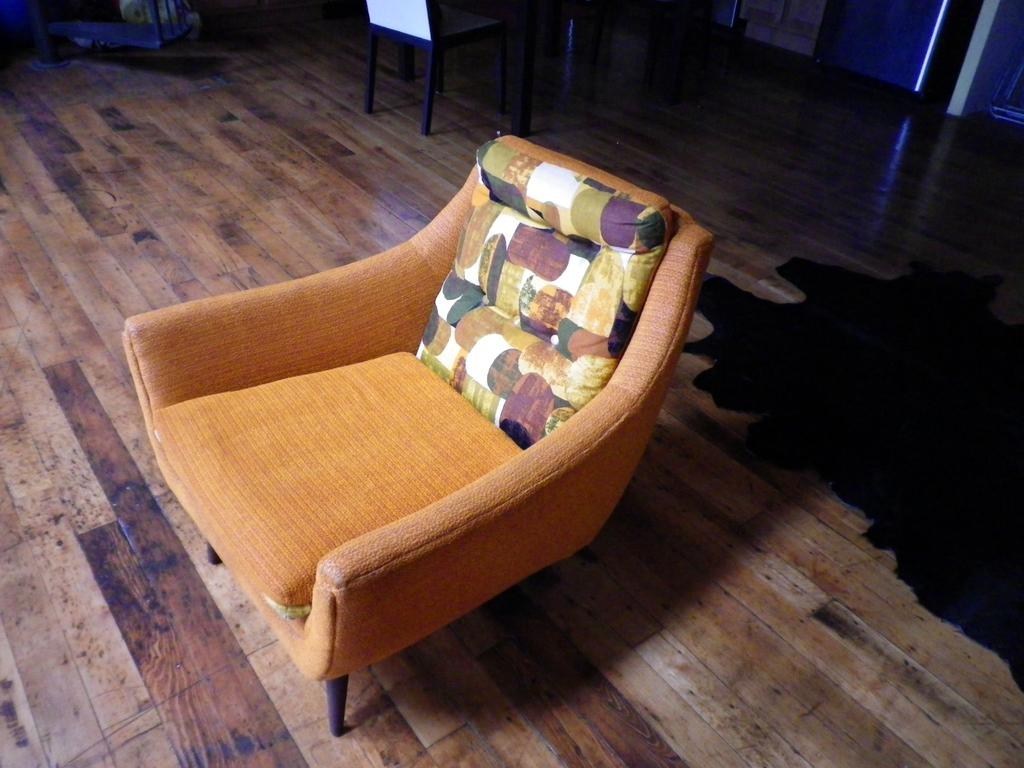What type of flooring is visible in the image? There is a wooden floor in the image. What furniture is placed on the wooden floor? There is a chair with a pillow on it and another chair on the wooden floor. Can you describe the position of the chairs in relation to each other? The first chair with a pillow is in front of the second chair on the wooden floor. How many firemen are sitting on the chairs in the image? There is no fireman present in the image; it only shows chairs on a wooden floor. What type of scale is used to weigh the chairs in the image? There is no scale present in the image, and the weight of the chairs is not relevant to the description of the image. 